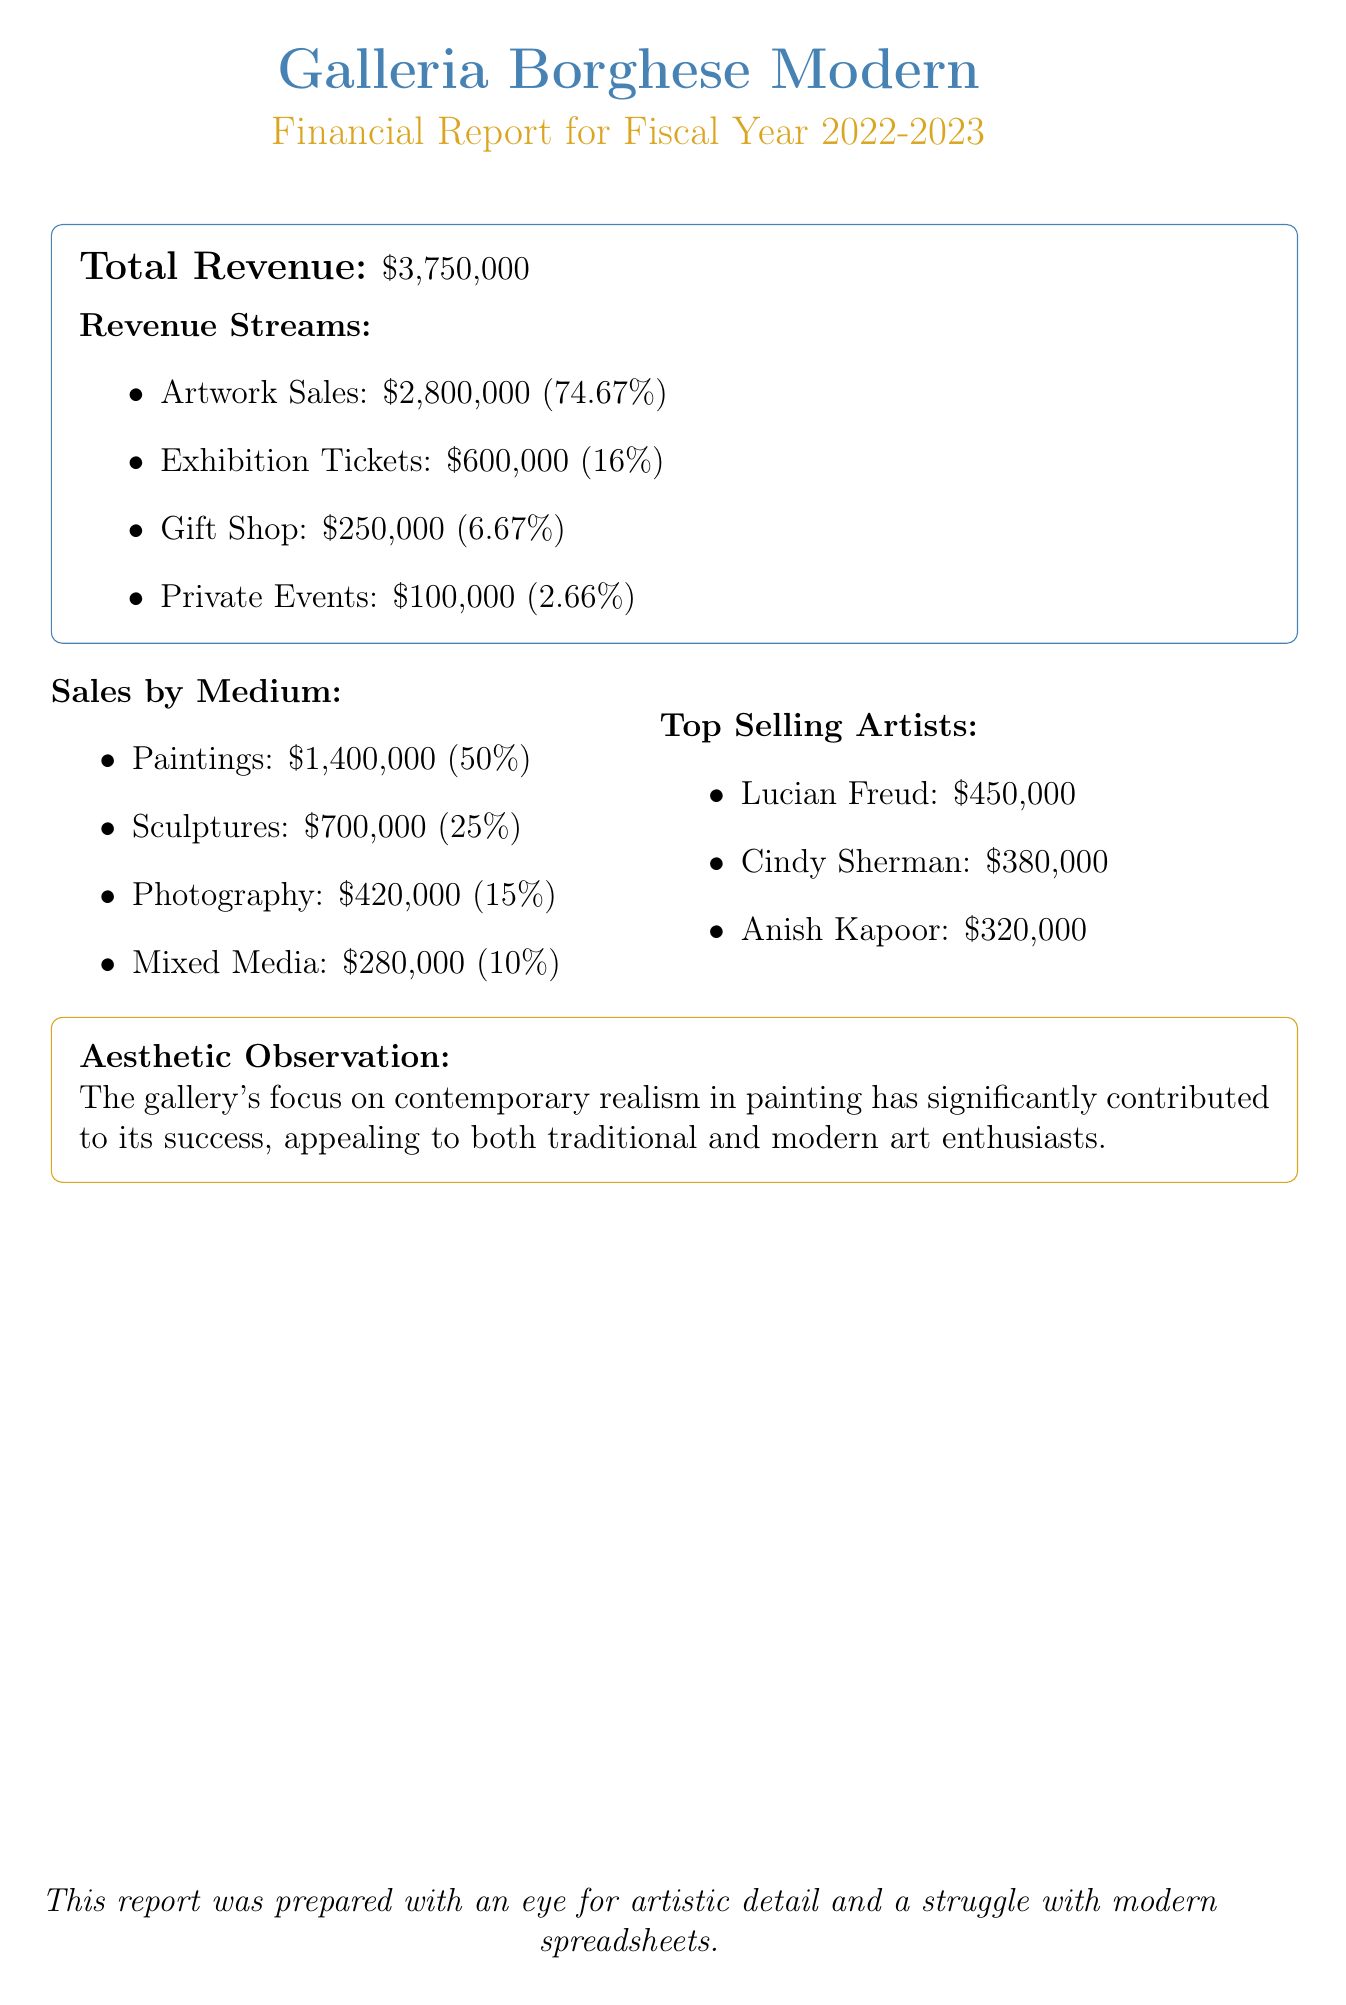What is the total revenue? The total revenue is stated as \$3,750,000 in the document.
Answer: \$3,750,000 What was the percentage of revenue from artwork sales? The document specifies that artwork sales contributed 74.67% to the total revenue.
Answer: 74.67% How much revenue did the gift shop generate? The document lists the amount generated by the gift shop as \$250,000.
Answer: \$250,000 Which artist had the highest sales? According to the document, Lucian Freud had the highest sales figure of \$450,000.
Answer: Lucian Freud What percentage of sales was attributed to sculptures? The document indicates that sculptures represented 25% of the sales.
Answer: 25% How much revenue did private events contribute? The document states that private events contributed \$100,000 to the total revenue.
Answer: \$100,000 What is the aesthetic observation about the gallery's focus? The document notes that the gallery's focus has significantly contributed to its success by appealing to different art enthusiasts.
Answer: Contemporary realism What is the total amount from exhibition tickets? The document provides the total amount from exhibition tickets as \$600,000.
Answer: \$600,000 What medium had the lowest sales? The document indicates that mixed media had the lowest sales amount of \$280,000.
Answer: Mixed Media 